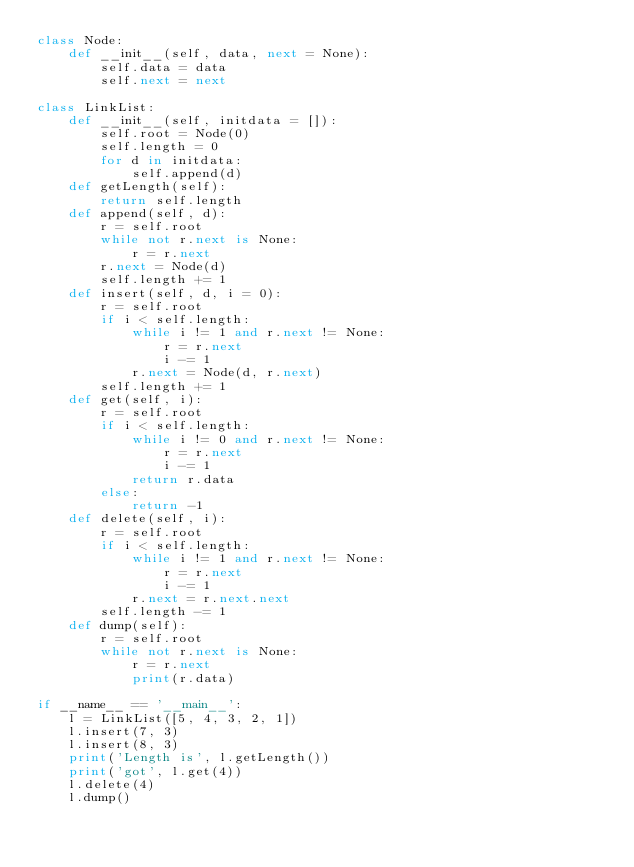Convert code to text. <code><loc_0><loc_0><loc_500><loc_500><_Python_>class Node:
    def __init__(self, data, next = None):
        self.data = data
        self.next = next

class LinkList:
    def __init__(self, initdata = []):
        self.root = Node(0)
        self.length = 0
        for d in initdata:
            self.append(d)
    def getLength(self):
        return self.length
    def append(self, d):
        r = self.root
        while not r.next is None:
            r = r.next
        r.next = Node(d)
        self.length += 1
    def insert(self, d, i = 0):
        r = self.root
        if i < self.length:
            while i != 1 and r.next != None:
                r = r.next
                i -= 1
            r.next = Node(d, r.next)
        self.length += 1
    def get(self, i):
        r = self.root
        if i < self.length:
            while i != 0 and r.next != None:
                r = r.next
                i -= 1
            return r.data
        else:
            return -1
    def delete(self, i):
        r = self.root
        if i < self.length:
            while i != 1 and r.next != None:
                r = r.next
                i -= 1
            r.next = r.next.next
        self.length -= 1
    def dump(self):
        r = self.root
        while not r.next is None:
            r = r.next
            print(r.data)

if __name__ == '__main__':
    l = LinkList([5, 4, 3, 2, 1])
    l.insert(7, 3)
    l.insert(8, 3)
    print('Length is', l.getLength())
    print('got', l.get(4))
    l.delete(4)
    l.dump()</code> 